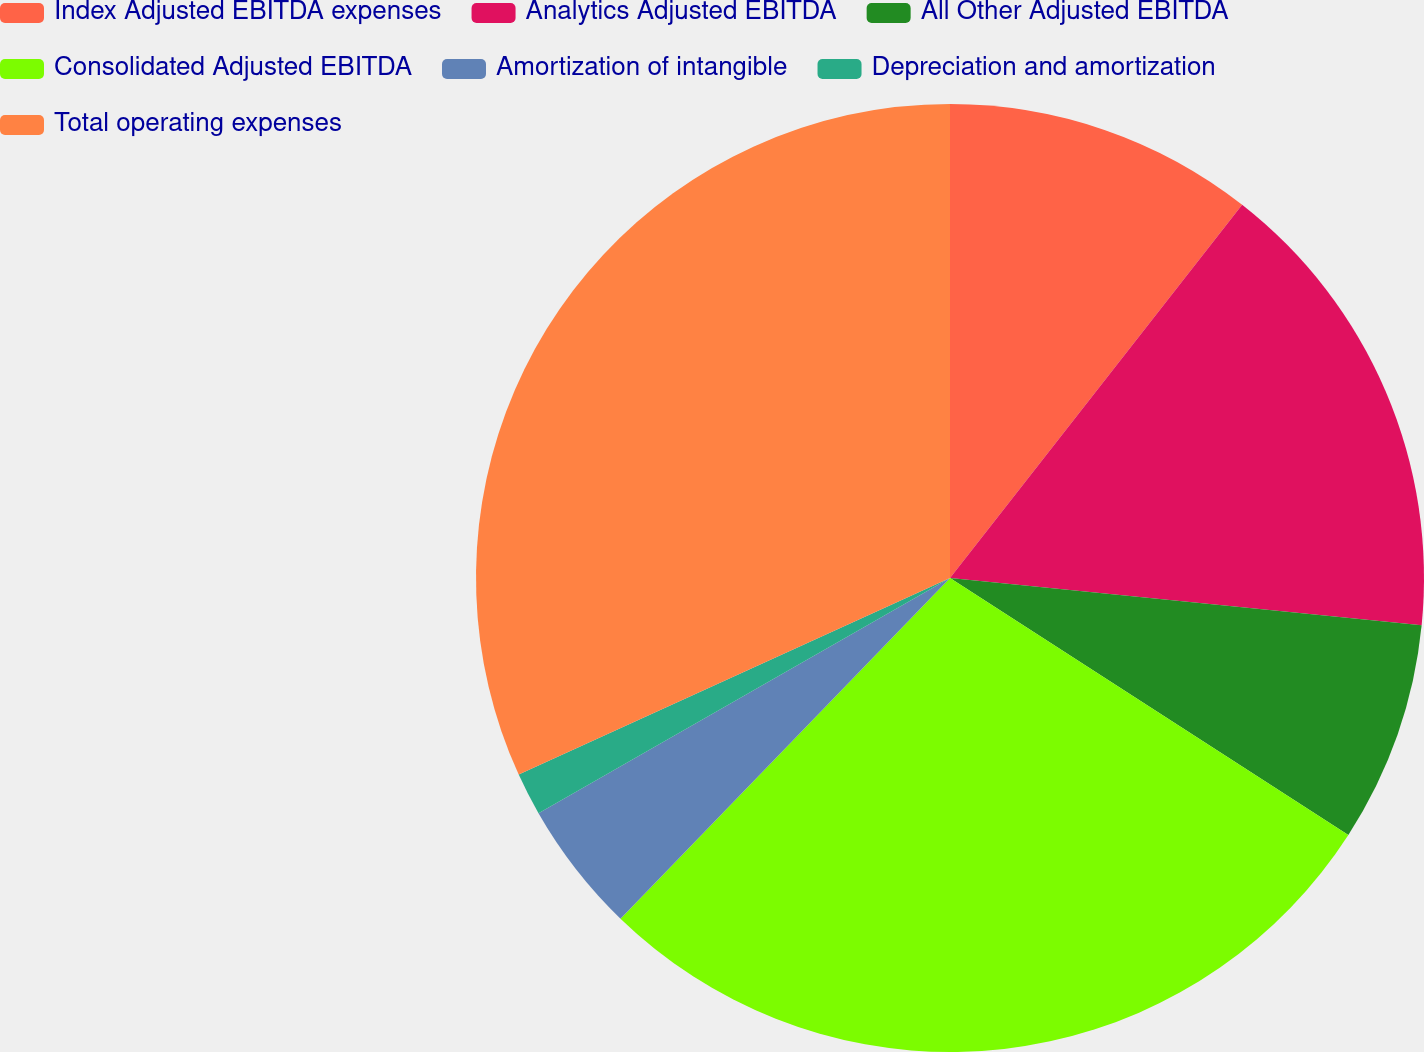Convert chart. <chart><loc_0><loc_0><loc_500><loc_500><pie_chart><fcel>Index Adjusted EBITDA expenses<fcel>Analytics Adjusted EBITDA<fcel>All Other Adjusted EBITDA<fcel>Consolidated Adjusted EBITDA<fcel>Amortization of intangible<fcel>Depreciation and amortization<fcel>Total operating expenses<nl><fcel>10.57%<fcel>16.02%<fcel>7.53%<fcel>28.12%<fcel>4.5%<fcel>1.46%<fcel>31.81%<nl></chart> 